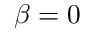Convert formula to latex. <formula><loc_0><loc_0><loc_500><loc_500>\beta = 0</formula> 